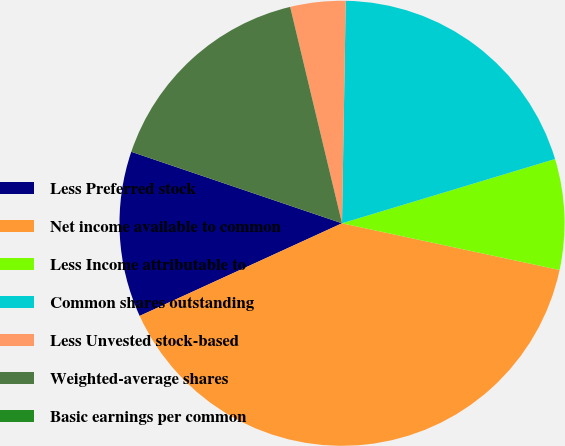Convert chart. <chart><loc_0><loc_0><loc_500><loc_500><pie_chart><fcel>Less Preferred stock<fcel>Net income available to common<fcel>Less Income attributable to<fcel>Common shares outstanding<fcel>Less Unvested stock-based<fcel>Weighted-average shares<fcel>Basic earnings per common<nl><fcel>12.04%<fcel>39.8%<fcel>8.03%<fcel>20.07%<fcel>4.01%<fcel>16.05%<fcel>0.0%<nl></chart> 